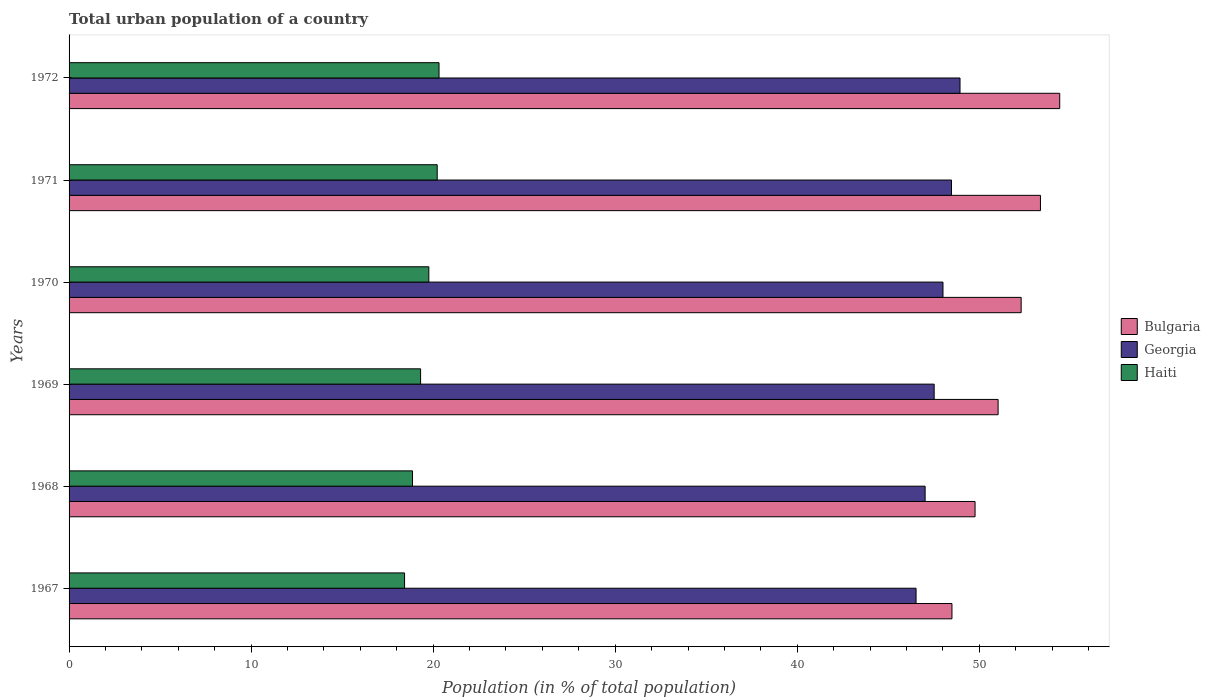How many different coloured bars are there?
Provide a short and direct response. 3. How many groups of bars are there?
Keep it short and to the point. 6. Are the number of bars per tick equal to the number of legend labels?
Offer a very short reply. Yes. Are the number of bars on each tick of the Y-axis equal?
Offer a terse response. Yes. What is the urban population in Georgia in 1968?
Provide a succinct answer. 47.02. Across all years, what is the maximum urban population in Haiti?
Keep it short and to the point. 20.32. Across all years, what is the minimum urban population in Georgia?
Your answer should be very brief. 46.53. In which year was the urban population in Bulgaria minimum?
Provide a succinct answer. 1967. What is the total urban population in Georgia in the graph?
Your answer should be compact. 286.5. What is the difference between the urban population in Georgia in 1967 and that in 1972?
Offer a very short reply. -2.41. What is the difference between the urban population in Haiti in 1971 and the urban population in Georgia in 1972?
Offer a very short reply. -28.72. What is the average urban population in Haiti per year?
Your answer should be very brief. 19.49. In the year 1969, what is the difference between the urban population in Haiti and urban population in Bulgaria?
Offer a very short reply. -31.72. What is the ratio of the urban population in Bulgaria in 1967 to that in 1972?
Your answer should be compact. 0.89. Is the urban population in Bulgaria in 1967 less than that in 1972?
Ensure brevity in your answer.  Yes. Is the difference between the urban population in Haiti in 1967 and 1970 greater than the difference between the urban population in Bulgaria in 1967 and 1970?
Offer a terse response. Yes. What is the difference between the highest and the second highest urban population in Georgia?
Keep it short and to the point. 0.47. What is the difference between the highest and the lowest urban population in Haiti?
Provide a succinct answer. 1.89. What does the 1st bar from the top in 1969 represents?
Ensure brevity in your answer.  Haiti. What does the 3rd bar from the bottom in 1969 represents?
Keep it short and to the point. Haiti. Is it the case that in every year, the sum of the urban population in Haiti and urban population in Georgia is greater than the urban population in Bulgaria?
Your response must be concise. Yes. How many bars are there?
Offer a very short reply. 18. Are all the bars in the graph horizontal?
Provide a succinct answer. Yes. What is the difference between two consecutive major ticks on the X-axis?
Your response must be concise. 10. Does the graph contain grids?
Give a very brief answer. No. How are the legend labels stacked?
Give a very brief answer. Vertical. What is the title of the graph?
Ensure brevity in your answer.  Total urban population of a country. Does "Comoros" appear as one of the legend labels in the graph?
Provide a succinct answer. No. What is the label or title of the X-axis?
Give a very brief answer. Population (in % of total population). What is the Population (in % of total population) in Bulgaria in 1967?
Make the answer very short. 48.5. What is the Population (in % of total population) in Georgia in 1967?
Keep it short and to the point. 46.53. What is the Population (in % of total population) in Haiti in 1967?
Provide a short and direct response. 18.43. What is the Population (in % of total population) in Bulgaria in 1968?
Your answer should be compact. 49.77. What is the Population (in % of total population) of Georgia in 1968?
Make the answer very short. 47.02. What is the Population (in % of total population) of Haiti in 1968?
Your answer should be very brief. 18.87. What is the Population (in % of total population) in Bulgaria in 1969?
Your answer should be very brief. 51.03. What is the Population (in % of total population) in Georgia in 1969?
Your response must be concise. 47.52. What is the Population (in % of total population) of Haiti in 1969?
Your answer should be very brief. 19.31. What is the Population (in % of total population) of Bulgaria in 1970?
Your response must be concise. 52.3. What is the Population (in % of total population) in Georgia in 1970?
Provide a short and direct response. 48.01. What is the Population (in % of total population) of Haiti in 1970?
Provide a succinct answer. 19.76. What is the Population (in % of total population) in Bulgaria in 1971?
Ensure brevity in your answer.  53.36. What is the Population (in % of total population) in Georgia in 1971?
Your response must be concise. 48.47. What is the Population (in % of total population) in Haiti in 1971?
Your response must be concise. 20.22. What is the Population (in % of total population) of Bulgaria in 1972?
Offer a terse response. 54.42. What is the Population (in % of total population) in Georgia in 1972?
Ensure brevity in your answer.  48.94. What is the Population (in % of total population) in Haiti in 1972?
Your answer should be compact. 20.32. Across all years, what is the maximum Population (in % of total population) in Bulgaria?
Offer a very short reply. 54.42. Across all years, what is the maximum Population (in % of total population) of Georgia?
Your answer should be compact. 48.94. Across all years, what is the maximum Population (in % of total population) in Haiti?
Your answer should be compact. 20.32. Across all years, what is the minimum Population (in % of total population) of Bulgaria?
Make the answer very short. 48.5. Across all years, what is the minimum Population (in % of total population) of Georgia?
Your answer should be very brief. 46.53. Across all years, what is the minimum Population (in % of total population) of Haiti?
Your answer should be very brief. 18.43. What is the total Population (in % of total population) of Bulgaria in the graph?
Your response must be concise. 309.38. What is the total Population (in % of total population) of Georgia in the graph?
Your answer should be compact. 286.5. What is the total Population (in % of total population) in Haiti in the graph?
Ensure brevity in your answer.  116.91. What is the difference between the Population (in % of total population) of Bulgaria in 1967 and that in 1968?
Make the answer very short. -1.27. What is the difference between the Population (in % of total population) in Georgia in 1967 and that in 1968?
Your answer should be compact. -0.5. What is the difference between the Population (in % of total population) of Haiti in 1967 and that in 1968?
Ensure brevity in your answer.  -0.44. What is the difference between the Population (in % of total population) of Bulgaria in 1967 and that in 1969?
Your answer should be very brief. -2.54. What is the difference between the Population (in % of total population) of Georgia in 1967 and that in 1969?
Provide a succinct answer. -0.99. What is the difference between the Population (in % of total population) in Haiti in 1967 and that in 1969?
Your answer should be very brief. -0.88. What is the difference between the Population (in % of total population) of Bulgaria in 1967 and that in 1970?
Make the answer very short. -3.8. What is the difference between the Population (in % of total population) of Georgia in 1967 and that in 1970?
Provide a short and direct response. -1.48. What is the difference between the Population (in % of total population) in Haiti in 1967 and that in 1970?
Provide a succinct answer. -1.33. What is the difference between the Population (in % of total population) in Bulgaria in 1967 and that in 1971?
Your answer should be compact. -4.86. What is the difference between the Population (in % of total population) of Georgia in 1967 and that in 1971?
Keep it short and to the point. -1.95. What is the difference between the Population (in % of total population) of Haiti in 1967 and that in 1971?
Provide a succinct answer. -1.79. What is the difference between the Population (in % of total population) of Bulgaria in 1967 and that in 1972?
Provide a short and direct response. -5.92. What is the difference between the Population (in % of total population) of Georgia in 1967 and that in 1972?
Your answer should be very brief. -2.42. What is the difference between the Population (in % of total population) of Haiti in 1967 and that in 1972?
Keep it short and to the point. -1.89. What is the difference between the Population (in % of total population) in Bulgaria in 1968 and that in 1969?
Provide a succinct answer. -1.27. What is the difference between the Population (in % of total population) of Georgia in 1968 and that in 1969?
Your answer should be very brief. -0.5. What is the difference between the Population (in % of total population) of Haiti in 1968 and that in 1969?
Your answer should be very brief. -0.44. What is the difference between the Population (in % of total population) of Bulgaria in 1968 and that in 1970?
Ensure brevity in your answer.  -2.53. What is the difference between the Population (in % of total population) of Georgia in 1968 and that in 1970?
Your answer should be very brief. -0.98. What is the difference between the Population (in % of total population) of Haiti in 1968 and that in 1970?
Give a very brief answer. -0.9. What is the difference between the Population (in % of total population) in Bulgaria in 1968 and that in 1971?
Provide a succinct answer. -3.59. What is the difference between the Population (in % of total population) of Georgia in 1968 and that in 1971?
Provide a succinct answer. -1.45. What is the difference between the Population (in % of total population) in Haiti in 1968 and that in 1971?
Your response must be concise. -1.36. What is the difference between the Population (in % of total population) in Bulgaria in 1968 and that in 1972?
Provide a succinct answer. -4.65. What is the difference between the Population (in % of total population) in Georgia in 1968 and that in 1972?
Keep it short and to the point. -1.92. What is the difference between the Population (in % of total population) of Haiti in 1968 and that in 1972?
Give a very brief answer. -1.46. What is the difference between the Population (in % of total population) of Bulgaria in 1969 and that in 1970?
Your response must be concise. -1.27. What is the difference between the Population (in % of total population) in Georgia in 1969 and that in 1970?
Provide a short and direct response. -0.48. What is the difference between the Population (in % of total population) in Haiti in 1969 and that in 1970?
Provide a succinct answer. -0.45. What is the difference between the Population (in % of total population) in Bulgaria in 1969 and that in 1971?
Offer a very short reply. -2.33. What is the difference between the Population (in % of total population) in Georgia in 1969 and that in 1971?
Make the answer very short. -0.95. What is the difference between the Population (in % of total population) of Haiti in 1969 and that in 1971?
Keep it short and to the point. -0.91. What is the difference between the Population (in % of total population) of Bulgaria in 1969 and that in 1972?
Your answer should be compact. -3.38. What is the difference between the Population (in % of total population) of Georgia in 1969 and that in 1972?
Provide a succinct answer. -1.42. What is the difference between the Population (in % of total population) of Haiti in 1969 and that in 1972?
Your response must be concise. -1.01. What is the difference between the Population (in % of total population) in Bulgaria in 1970 and that in 1971?
Ensure brevity in your answer.  -1.06. What is the difference between the Population (in % of total population) of Georgia in 1970 and that in 1971?
Offer a very short reply. -0.47. What is the difference between the Population (in % of total population) of Haiti in 1970 and that in 1971?
Ensure brevity in your answer.  -0.46. What is the difference between the Population (in % of total population) of Bulgaria in 1970 and that in 1972?
Your answer should be very brief. -2.12. What is the difference between the Population (in % of total population) in Georgia in 1970 and that in 1972?
Your answer should be very brief. -0.94. What is the difference between the Population (in % of total population) of Haiti in 1970 and that in 1972?
Provide a short and direct response. -0.56. What is the difference between the Population (in % of total population) in Bulgaria in 1971 and that in 1972?
Offer a terse response. -1.06. What is the difference between the Population (in % of total population) in Georgia in 1971 and that in 1972?
Provide a short and direct response. -0.47. What is the difference between the Population (in % of total population) of Haiti in 1971 and that in 1972?
Offer a terse response. -0.1. What is the difference between the Population (in % of total population) of Bulgaria in 1967 and the Population (in % of total population) of Georgia in 1968?
Ensure brevity in your answer.  1.47. What is the difference between the Population (in % of total population) in Bulgaria in 1967 and the Population (in % of total population) in Haiti in 1968?
Give a very brief answer. 29.63. What is the difference between the Population (in % of total population) of Georgia in 1967 and the Population (in % of total population) of Haiti in 1968?
Provide a succinct answer. 27.66. What is the difference between the Population (in % of total population) in Bulgaria in 1967 and the Population (in % of total population) in Georgia in 1969?
Your response must be concise. 0.98. What is the difference between the Population (in % of total population) in Bulgaria in 1967 and the Population (in % of total population) in Haiti in 1969?
Your answer should be compact. 29.19. What is the difference between the Population (in % of total population) in Georgia in 1967 and the Population (in % of total population) in Haiti in 1969?
Make the answer very short. 27.22. What is the difference between the Population (in % of total population) of Bulgaria in 1967 and the Population (in % of total population) of Georgia in 1970?
Offer a very short reply. 0.49. What is the difference between the Population (in % of total population) in Bulgaria in 1967 and the Population (in % of total population) in Haiti in 1970?
Your answer should be very brief. 28.74. What is the difference between the Population (in % of total population) of Georgia in 1967 and the Population (in % of total population) of Haiti in 1970?
Make the answer very short. 26.77. What is the difference between the Population (in % of total population) of Bulgaria in 1967 and the Population (in % of total population) of Georgia in 1971?
Offer a terse response. 0.03. What is the difference between the Population (in % of total population) in Bulgaria in 1967 and the Population (in % of total population) in Haiti in 1971?
Ensure brevity in your answer.  28.28. What is the difference between the Population (in % of total population) in Georgia in 1967 and the Population (in % of total population) in Haiti in 1971?
Ensure brevity in your answer.  26.3. What is the difference between the Population (in % of total population) in Bulgaria in 1967 and the Population (in % of total population) in Georgia in 1972?
Provide a short and direct response. -0.44. What is the difference between the Population (in % of total population) in Bulgaria in 1967 and the Population (in % of total population) in Haiti in 1972?
Offer a very short reply. 28.18. What is the difference between the Population (in % of total population) in Georgia in 1967 and the Population (in % of total population) in Haiti in 1972?
Make the answer very short. 26.2. What is the difference between the Population (in % of total population) of Bulgaria in 1968 and the Population (in % of total population) of Georgia in 1969?
Make the answer very short. 2.25. What is the difference between the Population (in % of total population) in Bulgaria in 1968 and the Population (in % of total population) in Haiti in 1969?
Your response must be concise. 30.46. What is the difference between the Population (in % of total population) of Georgia in 1968 and the Population (in % of total population) of Haiti in 1969?
Give a very brief answer. 27.71. What is the difference between the Population (in % of total population) in Bulgaria in 1968 and the Population (in % of total population) in Georgia in 1970?
Provide a succinct answer. 1.76. What is the difference between the Population (in % of total population) of Bulgaria in 1968 and the Population (in % of total population) of Haiti in 1970?
Provide a short and direct response. 30.01. What is the difference between the Population (in % of total population) of Georgia in 1968 and the Population (in % of total population) of Haiti in 1970?
Provide a short and direct response. 27.26. What is the difference between the Population (in % of total population) of Bulgaria in 1968 and the Population (in % of total population) of Georgia in 1971?
Keep it short and to the point. 1.29. What is the difference between the Population (in % of total population) in Bulgaria in 1968 and the Population (in % of total population) in Haiti in 1971?
Your response must be concise. 29.55. What is the difference between the Population (in % of total population) in Georgia in 1968 and the Population (in % of total population) in Haiti in 1971?
Offer a very short reply. 26.8. What is the difference between the Population (in % of total population) in Bulgaria in 1968 and the Population (in % of total population) in Georgia in 1972?
Keep it short and to the point. 0.83. What is the difference between the Population (in % of total population) of Bulgaria in 1968 and the Population (in % of total population) of Haiti in 1972?
Ensure brevity in your answer.  29.45. What is the difference between the Population (in % of total population) of Georgia in 1968 and the Population (in % of total population) of Haiti in 1972?
Give a very brief answer. 26.7. What is the difference between the Population (in % of total population) of Bulgaria in 1969 and the Population (in % of total population) of Georgia in 1970?
Provide a short and direct response. 3.03. What is the difference between the Population (in % of total population) in Bulgaria in 1969 and the Population (in % of total population) in Haiti in 1970?
Your answer should be very brief. 31.27. What is the difference between the Population (in % of total population) in Georgia in 1969 and the Population (in % of total population) in Haiti in 1970?
Offer a terse response. 27.76. What is the difference between the Population (in % of total population) in Bulgaria in 1969 and the Population (in % of total population) in Georgia in 1971?
Offer a very short reply. 2.56. What is the difference between the Population (in % of total population) of Bulgaria in 1969 and the Population (in % of total population) of Haiti in 1971?
Provide a succinct answer. 30.81. What is the difference between the Population (in % of total population) of Georgia in 1969 and the Population (in % of total population) of Haiti in 1971?
Give a very brief answer. 27.3. What is the difference between the Population (in % of total population) of Bulgaria in 1969 and the Population (in % of total population) of Georgia in 1972?
Provide a short and direct response. 2.09. What is the difference between the Population (in % of total population) of Bulgaria in 1969 and the Population (in % of total population) of Haiti in 1972?
Make the answer very short. 30.71. What is the difference between the Population (in % of total population) of Georgia in 1969 and the Population (in % of total population) of Haiti in 1972?
Provide a succinct answer. 27.2. What is the difference between the Population (in % of total population) in Bulgaria in 1970 and the Population (in % of total population) in Georgia in 1971?
Your response must be concise. 3.83. What is the difference between the Population (in % of total population) in Bulgaria in 1970 and the Population (in % of total population) in Haiti in 1971?
Keep it short and to the point. 32.08. What is the difference between the Population (in % of total population) of Georgia in 1970 and the Population (in % of total population) of Haiti in 1971?
Offer a very short reply. 27.78. What is the difference between the Population (in % of total population) of Bulgaria in 1970 and the Population (in % of total population) of Georgia in 1972?
Your response must be concise. 3.36. What is the difference between the Population (in % of total population) of Bulgaria in 1970 and the Population (in % of total population) of Haiti in 1972?
Offer a very short reply. 31.98. What is the difference between the Population (in % of total population) in Georgia in 1970 and the Population (in % of total population) in Haiti in 1972?
Give a very brief answer. 27.68. What is the difference between the Population (in % of total population) of Bulgaria in 1971 and the Population (in % of total population) of Georgia in 1972?
Your response must be concise. 4.42. What is the difference between the Population (in % of total population) of Bulgaria in 1971 and the Population (in % of total population) of Haiti in 1972?
Your answer should be very brief. 33.04. What is the difference between the Population (in % of total population) of Georgia in 1971 and the Population (in % of total population) of Haiti in 1972?
Offer a very short reply. 28.15. What is the average Population (in % of total population) in Bulgaria per year?
Provide a short and direct response. 51.56. What is the average Population (in % of total population) in Georgia per year?
Provide a succinct answer. 47.75. What is the average Population (in % of total population) in Haiti per year?
Your answer should be compact. 19.49. In the year 1967, what is the difference between the Population (in % of total population) in Bulgaria and Population (in % of total population) in Georgia?
Provide a short and direct response. 1.97. In the year 1967, what is the difference between the Population (in % of total population) of Bulgaria and Population (in % of total population) of Haiti?
Your answer should be compact. 30.07. In the year 1967, what is the difference between the Population (in % of total population) of Georgia and Population (in % of total population) of Haiti?
Offer a very short reply. 28.1. In the year 1968, what is the difference between the Population (in % of total population) of Bulgaria and Population (in % of total population) of Georgia?
Your answer should be compact. 2.74. In the year 1968, what is the difference between the Population (in % of total population) in Bulgaria and Population (in % of total population) in Haiti?
Provide a succinct answer. 30.9. In the year 1968, what is the difference between the Population (in % of total population) in Georgia and Population (in % of total population) in Haiti?
Your response must be concise. 28.16. In the year 1969, what is the difference between the Population (in % of total population) of Bulgaria and Population (in % of total population) of Georgia?
Your response must be concise. 3.51. In the year 1969, what is the difference between the Population (in % of total population) in Bulgaria and Population (in % of total population) in Haiti?
Provide a short and direct response. 31.72. In the year 1969, what is the difference between the Population (in % of total population) of Georgia and Population (in % of total population) of Haiti?
Give a very brief answer. 28.21. In the year 1970, what is the difference between the Population (in % of total population) in Bulgaria and Population (in % of total population) in Georgia?
Provide a succinct answer. 4.29. In the year 1970, what is the difference between the Population (in % of total population) in Bulgaria and Population (in % of total population) in Haiti?
Provide a short and direct response. 32.54. In the year 1970, what is the difference between the Population (in % of total population) of Georgia and Population (in % of total population) of Haiti?
Your response must be concise. 28.24. In the year 1971, what is the difference between the Population (in % of total population) in Bulgaria and Population (in % of total population) in Georgia?
Your answer should be very brief. 4.89. In the year 1971, what is the difference between the Population (in % of total population) in Bulgaria and Population (in % of total population) in Haiti?
Offer a very short reply. 33.14. In the year 1971, what is the difference between the Population (in % of total population) of Georgia and Population (in % of total population) of Haiti?
Offer a very short reply. 28.25. In the year 1972, what is the difference between the Population (in % of total population) in Bulgaria and Population (in % of total population) in Georgia?
Ensure brevity in your answer.  5.48. In the year 1972, what is the difference between the Population (in % of total population) in Bulgaria and Population (in % of total population) in Haiti?
Provide a succinct answer. 34.1. In the year 1972, what is the difference between the Population (in % of total population) of Georgia and Population (in % of total population) of Haiti?
Provide a short and direct response. 28.62. What is the ratio of the Population (in % of total population) in Bulgaria in 1967 to that in 1968?
Give a very brief answer. 0.97. What is the ratio of the Population (in % of total population) in Georgia in 1967 to that in 1968?
Offer a terse response. 0.99. What is the ratio of the Population (in % of total population) in Haiti in 1967 to that in 1968?
Make the answer very short. 0.98. What is the ratio of the Population (in % of total population) of Bulgaria in 1967 to that in 1969?
Your answer should be compact. 0.95. What is the ratio of the Population (in % of total population) of Georgia in 1967 to that in 1969?
Your answer should be very brief. 0.98. What is the ratio of the Population (in % of total population) of Haiti in 1967 to that in 1969?
Your answer should be compact. 0.95. What is the ratio of the Population (in % of total population) of Bulgaria in 1967 to that in 1970?
Offer a very short reply. 0.93. What is the ratio of the Population (in % of total population) of Georgia in 1967 to that in 1970?
Offer a terse response. 0.97. What is the ratio of the Population (in % of total population) of Haiti in 1967 to that in 1970?
Your answer should be compact. 0.93. What is the ratio of the Population (in % of total population) in Bulgaria in 1967 to that in 1971?
Your answer should be very brief. 0.91. What is the ratio of the Population (in % of total population) in Georgia in 1967 to that in 1971?
Make the answer very short. 0.96. What is the ratio of the Population (in % of total population) in Haiti in 1967 to that in 1971?
Give a very brief answer. 0.91. What is the ratio of the Population (in % of total population) of Bulgaria in 1967 to that in 1972?
Give a very brief answer. 0.89. What is the ratio of the Population (in % of total population) of Georgia in 1967 to that in 1972?
Ensure brevity in your answer.  0.95. What is the ratio of the Population (in % of total population) of Haiti in 1967 to that in 1972?
Make the answer very short. 0.91. What is the ratio of the Population (in % of total population) of Bulgaria in 1968 to that in 1969?
Keep it short and to the point. 0.98. What is the ratio of the Population (in % of total population) of Bulgaria in 1968 to that in 1970?
Your answer should be very brief. 0.95. What is the ratio of the Population (in % of total population) in Georgia in 1968 to that in 1970?
Offer a very short reply. 0.98. What is the ratio of the Population (in % of total population) of Haiti in 1968 to that in 1970?
Offer a terse response. 0.95. What is the ratio of the Population (in % of total population) of Bulgaria in 1968 to that in 1971?
Your response must be concise. 0.93. What is the ratio of the Population (in % of total population) of Georgia in 1968 to that in 1971?
Offer a terse response. 0.97. What is the ratio of the Population (in % of total population) in Haiti in 1968 to that in 1971?
Ensure brevity in your answer.  0.93. What is the ratio of the Population (in % of total population) of Bulgaria in 1968 to that in 1972?
Your answer should be very brief. 0.91. What is the ratio of the Population (in % of total population) in Georgia in 1968 to that in 1972?
Your answer should be very brief. 0.96. What is the ratio of the Population (in % of total population) of Haiti in 1968 to that in 1972?
Your answer should be compact. 0.93. What is the ratio of the Population (in % of total population) of Bulgaria in 1969 to that in 1970?
Offer a terse response. 0.98. What is the ratio of the Population (in % of total population) in Georgia in 1969 to that in 1970?
Make the answer very short. 0.99. What is the ratio of the Population (in % of total population) in Haiti in 1969 to that in 1970?
Your answer should be compact. 0.98. What is the ratio of the Population (in % of total population) in Bulgaria in 1969 to that in 1971?
Provide a short and direct response. 0.96. What is the ratio of the Population (in % of total population) of Georgia in 1969 to that in 1971?
Keep it short and to the point. 0.98. What is the ratio of the Population (in % of total population) of Haiti in 1969 to that in 1971?
Offer a very short reply. 0.95. What is the ratio of the Population (in % of total population) of Bulgaria in 1969 to that in 1972?
Make the answer very short. 0.94. What is the ratio of the Population (in % of total population) in Georgia in 1969 to that in 1972?
Provide a short and direct response. 0.97. What is the ratio of the Population (in % of total population) in Haiti in 1969 to that in 1972?
Offer a terse response. 0.95. What is the ratio of the Population (in % of total population) of Bulgaria in 1970 to that in 1971?
Offer a terse response. 0.98. What is the ratio of the Population (in % of total population) of Georgia in 1970 to that in 1971?
Provide a short and direct response. 0.99. What is the ratio of the Population (in % of total population) in Haiti in 1970 to that in 1971?
Your answer should be very brief. 0.98. What is the ratio of the Population (in % of total population) in Bulgaria in 1970 to that in 1972?
Ensure brevity in your answer.  0.96. What is the ratio of the Population (in % of total population) of Georgia in 1970 to that in 1972?
Offer a very short reply. 0.98. What is the ratio of the Population (in % of total population) in Haiti in 1970 to that in 1972?
Your response must be concise. 0.97. What is the ratio of the Population (in % of total population) of Bulgaria in 1971 to that in 1972?
Your answer should be compact. 0.98. What is the ratio of the Population (in % of total population) in Georgia in 1971 to that in 1972?
Keep it short and to the point. 0.99. What is the difference between the highest and the second highest Population (in % of total population) in Bulgaria?
Provide a short and direct response. 1.06. What is the difference between the highest and the second highest Population (in % of total population) in Georgia?
Your response must be concise. 0.47. What is the difference between the highest and the second highest Population (in % of total population) of Haiti?
Your answer should be compact. 0.1. What is the difference between the highest and the lowest Population (in % of total population) in Bulgaria?
Ensure brevity in your answer.  5.92. What is the difference between the highest and the lowest Population (in % of total population) in Georgia?
Provide a short and direct response. 2.42. What is the difference between the highest and the lowest Population (in % of total population) in Haiti?
Offer a very short reply. 1.89. 